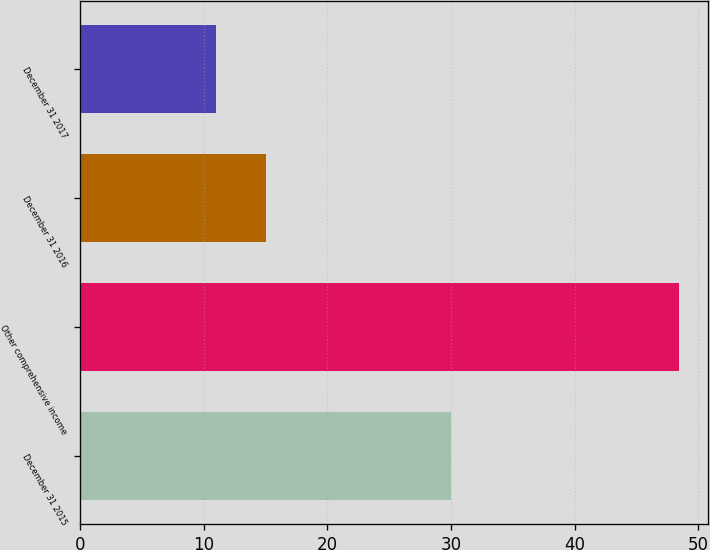Convert chart. <chart><loc_0><loc_0><loc_500><loc_500><bar_chart><fcel>December 31 2015<fcel>Other comprehensive income<fcel>December 31 2016<fcel>December 31 2017<nl><fcel>30<fcel>48.4<fcel>15<fcel>11<nl></chart> 